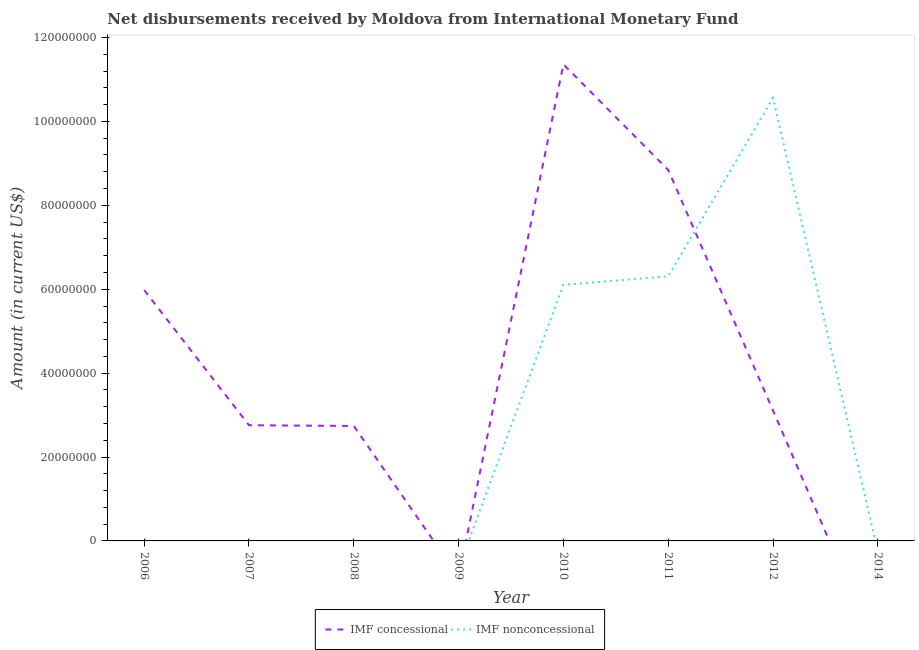Is the number of lines equal to the number of legend labels?
Make the answer very short. No. What is the net concessional disbursements from imf in 2008?
Make the answer very short. 2.74e+07. Across all years, what is the maximum net concessional disbursements from imf?
Make the answer very short. 1.14e+08. Across all years, what is the minimum net concessional disbursements from imf?
Your answer should be compact. 0. In which year was the net concessional disbursements from imf maximum?
Your answer should be compact. 2010. What is the total net concessional disbursements from imf in the graph?
Provide a succinct answer. 3.48e+08. What is the difference between the net concessional disbursements from imf in 2006 and that in 2010?
Keep it short and to the point. -5.38e+07. What is the difference between the net concessional disbursements from imf in 2012 and the net non concessional disbursements from imf in 2006?
Give a very brief answer. 3.11e+07. What is the average net non concessional disbursements from imf per year?
Make the answer very short. 2.87e+07. In the year 2012, what is the difference between the net concessional disbursements from imf and net non concessional disbursements from imf?
Make the answer very short. -7.45e+07. In how many years, is the net concessional disbursements from imf greater than 64000000 US$?
Offer a terse response. 2. What is the ratio of the net concessional disbursements from imf in 2006 to that in 2008?
Provide a short and direct response. 2.18. What is the difference between the highest and the second highest net non concessional disbursements from imf?
Your answer should be compact. 4.25e+07. What is the difference between the highest and the lowest net non concessional disbursements from imf?
Provide a short and direct response. 1.06e+08. Does the net non concessional disbursements from imf monotonically increase over the years?
Give a very brief answer. No. Is the net non concessional disbursements from imf strictly greater than the net concessional disbursements from imf over the years?
Provide a succinct answer. No. How many lines are there?
Give a very brief answer. 2. What is the difference between two consecutive major ticks on the Y-axis?
Your answer should be very brief. 2.00e+07. Are the values on the major ticks of Y-axis written in scientific E-notation?
Ensure brevity in your answer.  No. How many legend labels are there?
Your answer should be compact. 2. What is the title of the graph?
Provide a short and direct response. Net disbursements received by Moldova from International Monetary Fund. Does "Diarrhea" appear as one of the legend labels in the graph?
Your response must be concise. No. What is the label or title of the X-axis?
Your answer should be compact. Year. What is the label or title of the Y-axis?
Keep it short and to the point. Amount (in current US$). What is the Amount (in current US$) in IMF concessional in 2006?
Give a very brief answer. 5.98e+07. What is the Amount (in current US$) of IMF nonconcessional in 2006?
Provide a short and direct response. 0. What is the Amount (in current US$) in IMF concessional in 2007?
Provide a short and direct response. 2.76e+07. What is the Amount (in current US$) in IMF concessional in 2008?
Give a very brief answer. 2.74e+07. What is the Amount (in current US$) in IMF concessional in 2009?
Keep it short and to the point. 0. What is the Amount (in current US$) in IMF nonconcessional in 2009?
Make the answer very short. 0. What is the Amount (in current US$) of IMF concessional in 2010?
Your response must be concise. 1.14e+08. What is the Amount (in current US$) in IMF nonconcessional in 2010?
Provide a short and direct response. 6.10e+07. What is the Amount (in current US$) of IMF concessional in 2011?
Ensure brevity in your answer.  8.84e+07. What is the Amount (in current US$) of IMF nonconcessional in 2011?
Offer a terse response. 6.31e+07. What is the Amount (in current US$) in IMF concessional in 2012?
Provide a short and direct response. 3.11e+07. What is the Amount (in current US$) of IMF nonconcessional in 2012?
Your answer should be compact. 1.06e+08. What is the Amount (in current US$) in IMF concessional in 2014?
Offer a terse response. 0. What is the Amount (in current US$) in IMF nonconcessional in 2014?
Give a very brief answer. 0. Across all years, what is the maximum Amount (in current US$) of IMF concessional?
Make the answer very short. 1.14e+08. Across all years, what is the maximum Amount (in current US$) in IMF nonconcessional?
Give a very brief answer. 1.06e+08. What is the total Amount (in current US$) of IMF concessional in the graph?
Ensure brevity in your answer.  3.48e+08. What is the total Amount (in current US$) of IMF nonconcessional in the graph?
Make the answer very short. 2.30e+08. What is the difference between the Amount (in current US$) of IMF concessional in 2006 and that in 2007?
Make the answer very short. 3.22e+07. What is the difference between the Amount (in current US$) of IMF concessional in 2006 and that in 2008?
Give a very brief answer. 3.24e+07. What is the difference between the Amount (in current US$) of IMF concessional in 2006 and that in 2010?
Your answer should be compact. -5.38e+07. What is the difference between the Amount (in current US$) of IMF concessional in 2006 and that in 2011?
Provide a succinct answer. -2.86e+07. What is the difference between the Amount (in current US$) in IMF concessional in 2006 and that in 2012?
Offer a very short reply. 2.87e+07. What is the difference between the Amount (in current US$) of IMF concessional in 2007 and that in 2008?
Keep it short and to the point. 1.74e+05. What is the difference between the Amount (in current US$) of IMF concessional in 2007 and that in 2010?
Offer a terse response. -8.60e+07. What is the difference between the Amount (in current US$) in IMF concessional in 2007 and that in 2011?
Your answer should be very brief. -6.09e+07. What is the difference between the Amount (in current US$) in IMF concessional in 2007 and that in 2012?
Offer a terse response. -3.51e+06. What is the difference between the Amount (in current US$) in IMF concessional in 2008 and that in 2010?
Offer a very short reply. -8.62e+07. What is the difference between the Amount (in current US$) in IMF concessional in 2008 and that in 2011?
Offer a terse response. -6.10e+07. What is the difference between the Amount (in current US$) in IMF concessional in 2008 and that in 2012?
Offer a very short reply. -3.68e+06. What is the difference between the Amount (in current US$) of IMF concessional in 2010 and that in 2011?
Ensure brevity in your answer.  2.52e+07. What is the difference between the Amount (in current US$) in IMF nonconcessional in 2010 and that in 2011?
Give a very brief answer. -2.03e+06. What is the difference between the Amount (in current US$) in IMF concessional in 2010 and that in 2012?
Offer a very short reply. 8.25e+07. What is the difference between the Amount (in current US$) in IMF nonconcessional in 2010 and that in 2012?
Your answer should be very brief. -4.45e+07. What is the difference between the Amount (in current US$) in IMF concessional in 2011 and that in 2012?
Your answer should be compact. 5.73e+07. What is the difference between the Amount (in current US$) in IMF nonconcessional in 2011 and that in 2012?
Ensure brevity in your answer.  -4.25e+07. What is the difference between the Amount (in current US$) of IMF concessional in 2006 and the Amount (in current US$) of IMF nonconcessional in 2010?
Your answer should be compact. -1.24e+06. What is the difference between the Amount (in current US$) of IMF concessional in 2006 and the Amount (in current US$) of IMF nonconcessional in 2011?
Keep it short and to the point. -3.28e+06. What is the difference between the Amount (in current US$) in IMF concessional in 2006 and the Amount (in current US$) in IMF nonconcessional in 2012?
Offer a terse response. -4.58e+07. What is the difference between the Amount (in current US$) in IMF concessional in 2007 and the Amount (in current US$) in IMF nonconcessional in 2010?
Ensure brevity in your answer.  -3.35e+07. What is the difference between the Amount (in current US$) of IMF concessional in 2007 and the Amount (in current US$) of IMF nonconcessional in 2011?
Your answer should be very brief. -3.55e+07. What is the difference between the Amount (in current US$) in IMF concessional in 2007 and the Amount (in current US$) in IMF nonconcessional in 2012?
Give a very brief answer. -7.80e+07. What is the difference between the Amount (in current US$) in IMF concessional in 2008 and the Amount (in current US$) in IMF nonconcessional in 2010?
Your answer should be compact. -3.36e+07. What is the difference between the Amount (in current US$) in IMF concessional in 2008 and the Amount (in current US$) in IMF nonconcessional in 2011?
Your response must be concise. -3.57e+07. What is the difference between the Amount (in current US$) in IMF concessional in 2008 and the Amount (in current US$) in IMF nonconcessional in 2012?
Give a very brief answer. -7.82e+07. What is the difference between the Amount (in current US$) in IMF concessional in 2010 and the Amount (in current US$) in IMF nonconcessional in 2011?
Your answer should be compact. 5.05e+07. What is the difference between the Amount (in current US$) of IMF concessional in 2010 and the Amount (in current US$) of IMF nonconcessional in 2012?
Ensure brevity in your answer.  8.03e+06. What is the difference between the Amount (in current US$) of IMF concessional in 2011 and the Amount (in current US$) of IMF nonconcessional in 2012?
Provide a succinct answer. -1.72e+07. What is the average Amount (in current US$) of IMF concessional per year?
Your answer should be very brief. 4.35e+07. What is the average Amount (in current US$) in IMF nonconcessional per year?
Provide a succinct answer. 2.87e+07. In the year 2010, what is the difference between the Amount (in current US$) of IMF concessional and Amount (in current US$) of IMF nonconcessional?
Offer a terse response. 5.26e+07. In the year 2011, what is the difference between the Amount (in current US$) in IMF concessional and Amount (in current US$) in IMF nonconcessional?
Keep it short and to the point. 2.54e+07. In the year 2012, what is the difference between the Amount (in current US$) in IMF concessional and Amount (in current US$) in IMF nonconcessional?
Your response must be concise. -7.45e+07. What is the ratio of the Amount (in current US$) in IMF concessional in 2006 to that in 2007?
Provide a short and direct response. 2.17. What is the ratio of the Amount (in current US$) in IMF concessional in 2006 to that in 2008?
Your answer should be very brief. 2.18. What is the ratio of the Amount (in current US$) in IMF concessional in 2006 to that in 2010?
Offer a very short reply. 0.53. What is the ratio of the Amount (in current US$) in IMF concessional in 2006 to that in 2011?
Make the answer very short. 0.68. What is the ratio of the Amount (in current US$) of IMF concessional in 2006 to that in 2012?
Offer a terse response. 1.92. What is the ratio of the Amount (in current US$) of IMF concessional in 2007 to that in 2010?
Make the answer very short. 0.24. What is the ratio of the Amount (in current US$) in IMF concessional in 2007 to that in 2011?
Give a very brief answer. 0.31. What is the ratio of the Amount (in current US$) in IMF concessional in 2007 to that in 2012?
Make the answer very short. 0.89. What is the ratio of the Amount (in current US$) in IMF concessional in 2008 to that in 2010?
Give a very brief answer. 0.24. What is the ratio of the Amount (in current US$) of IMF concessional in 2008 to that in 2011?
Offer a terse response. 0.31. What is the ratio of the Amount (in current US$) in IMF concessional in 2008 to that in 2012?
Ensure brevity in your answer.  0.88. What is the ratio of the Amount (in current US$) of IMF concessional in 2010 to that in 2011?
Your answer should be compact. 1.28. What is the ratio of the Amount (in current US$) of IMF nonconcessional in 2010 to that in 2011?
Keep it short and to the point. 0.97. What is the ratio of the Amount (in current US$) in IMF concessional in 2010 to that in 2012?
Your answer should be compact. 3.65. What is the ratio of the Amount (in current US$) of IMF nonconcessional in 2010 to that in 2012?
Your answer should be compact. 0.58. What is the ratio of the Amount (in current US$) of IMF concessional in 2011 to that in 2012?
Offer a terse response. 2.84. What is the ratio of the Amount (in current US$) in IMF nonconcessional in 2011 to that in 2012?
Make the answer very short. 0.6. What is the difference between the highest and the second highest Amount (in current US$) of IMF concessional?
Ensure brevity in your answer.  2.52e+07. What is the difference between the highest and the second highest Amount (in current US$) of IMF nonconcessional?
Give a very brief answer. 4.25e+07. What is the difference between the highest and the lowest Amount (in current US$) in IMF concessional?
Offer a very short reply. 1.14e+08. What is the difference between the highest and the lowest Amount (in current US$) of IMF nonconcessional?
Your answer should be compact. 1.06e+08. 